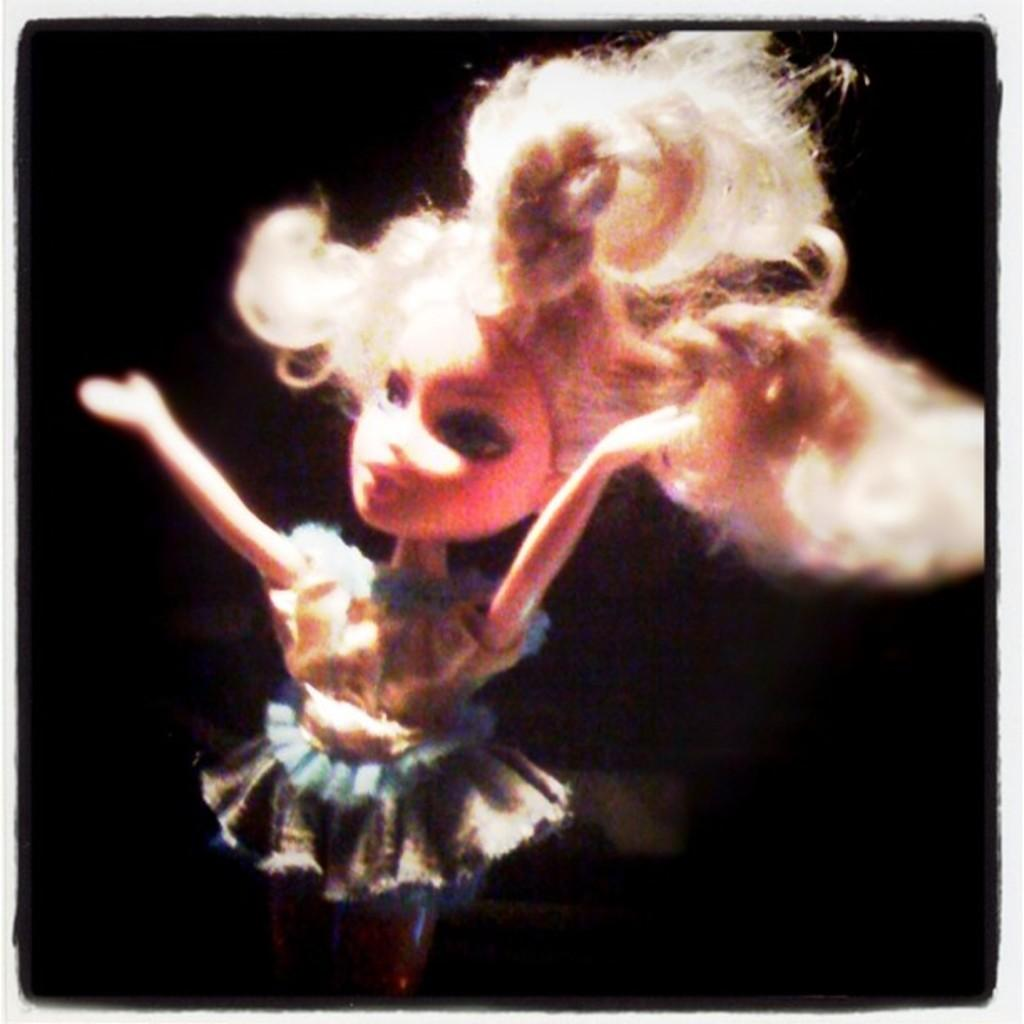What type of toy is in the image? There is a girl toy in the image. What color is the background of the image? The background of the image is black. Are there any design elements around the image? Yes, the image has borders. What word is written on the toy in the image? There is no word written on the toy in the image. What color is the carpenter's apron in the image? There is no carpenter present in the image. 